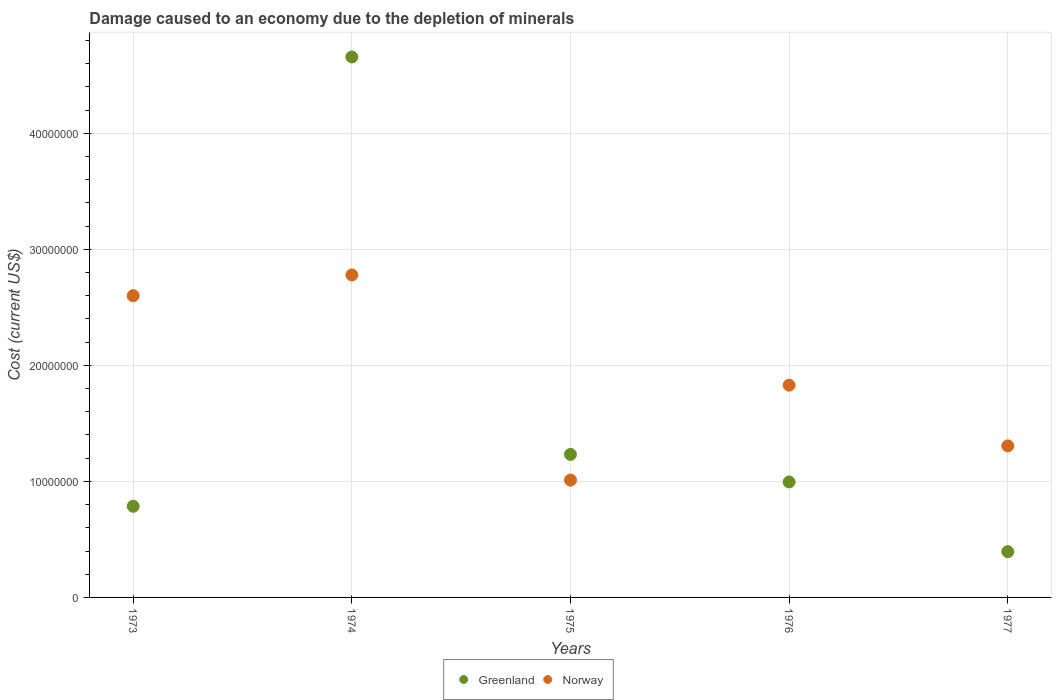How many different coloured dotlines are there?
Keep it short and to the point. 2. What is the cost of damage caused due to the depletion of minerals in Norway in 1975?
Offer a terse response. 1.01e+07. Across all years, what is the maximum cost of damage caused due to the depletion of minerals in Norway?
Give a very brief answer. 2.78e+07. Across all years, what is the minimum cost of damage caused due to the depletion of minerals in Norway?
Make the answer very short. 1.01e+07. In which year was the cost of damage caused due to the depletion of minerals in Norway maximum?
Provide a short and direct response. 1974. In which year was the cost of damage caused due to the depletion of minerals in Norway minimum?
Your answer should be very brief. 1975. What is the total cost of damage caused due to the depletion of minerals in Norway in the graph?
Ensure brevity in your answer.  9.53e+07. What is the difference between the cost of damage caused due to the depletion of minerals in Norway in 1974 and that in 1976?
Provide a succinct answer. 9.50e+06. What is the difference between the cost of damage caused due to the depletion of minerals in Greenland in 1975 and the cost of damage caused due to the depletion of minerals in Norway in 1974?
Your response must be concise. -1.55e+07. What is the average cost of damage caused due to the depletion of minerals in Norway per year?
Ensure brevity in your answer.  1.91e+07. In the year 1973, what is the difference between the cost of damage caused due to the depletion of minerals in Norway and cost of damage caused due to the depletion of minerals in Greenland?
Your response must be concise. 1.82e+07. What is the ratio of the cost of damage caused due to the depletion of minerals in Norway in 1974 to that in 1976?
Your answer should be very brief. 1.52. Is the cost of damage caused due to the depletion of minerals in Greenland in 1973 less than that in 1975?
Your answer should be compact. Yes. Is the difference between the cost of damage caused due to the depletion of minerals in Norway in 1976 and 1977 greater than the difference between the cost of damage caused due to the depletion of minerals in Greenland in 1976 and 1977?
Ensure brevity in your answer.  No. What is the difference between the highest and the second highest cost of damage caused due to the depletion of minerals in Norway?
Your answer should be compact. 1.79e+06. What is the difference between the highest and the lowest cost of damage caused due to the depletion of minerals in Norway?
Offer a terse response. 1.77e+07. Does the cost of damage caused due to the depletion of minerals in Norway monotonically increase over the years?
Keep it short and to the point. No. Is the cost of damage caused due to the depletion of minerals in Norway strictly greater than the cost of damage caused due to the depletion of minerals in Greenland over the years?
Ensure brevity in your answer.  No. How many dotlines are there?
Ensure brevity in your answer.  2. What is the difference between two consecutive major ticks on the Y-axis?
Your answer should be compact. 1.00e+07. Are the values on the major ticks of Y-axis written in scientific E-notation?
Provide a short and direct response. No. How are the legend labels stacked?
Provide a succinct answer. Horizontal. What is the title of the graph?
Offer a very short reply. Damage caused to an economy due to the depletion of minerals. Does "Hungary" appear as one of the legend labels in the graph?
Give a very brief answer. No. What is the label or title of the X-axis?
Offer a terse response. Years. What is the label or title of the Y-axis?
Ensure brevity in your answer.  Cost (current US$). What is the Cost (current US$) in Greenland in 1973?
Offer a terse response. 7.86e+06. What is the Cost (current US$) of Norway in 1973?
Offer a very short reply. 2.60e+07. What is the Cost (current US$) in Greenland in 1974?
Your answer should be very brief. 4.66e+07. What is the Cost (current US$) of Norway in 1974?
Provide a short and direct response. 2.78e+07. What is the Cost (current US$) of Greenland in 1975?
Offer a very short reply. 1.23e+07. What is the Cost (current US$) of Norway in 1975?
Provide a succinct answer. 1.01e+07. What is the Cost (current US$) in Greenland in 1976?
Your answer should be very brief. 9.95e+06. What is the Cost (current US$) in Norway in 1976?
Make the answer very short. 1.83e+07. What is the Cost (current US$) in Greenland in 1977?
Your answer should be very brief. 3.94e+06. What is the Cost (current US$) in Norway in 1977?
Make the answer very short. 1.31e+07. Across all years, what is the maximum Cost (current US$) of Greenland?
Provide a short and direct response. 4.66e+07. Across all years, what is the maximum Cost (current US$) in Norway?
Make the answer very short. 2.78e+07. Across all years, what is the minimum Cost (current US$) in Greenland?
Provide a short and direct response. 3.94e+06. Across all years, what is the minimum Cost (current US$) of Norway?
Make the answer very short. 1.01e+07. What is the total Cost (current US$) of Greenland in the graph?
Offer a very short reply. 8.07e+07. What is the total Cost (current US$) of Norway in the graph?
Ensure brevity in your answer.  9.53e+07. What is the difference between the Cost (current US$) of Greenland in 1973 and that in 1974?
Make the answer very short. -3.87e+07. What is the difference between the Cost (current US$) in Norway in 1973 and that in 1974?
Provide a succinct answer. -1.79e+06. What is the difference between the Cost (current US$) in Greenland in 1973 and that in 1975?
Your answer should be very brief. -4.47e+06. What is the difference between the Cost (current US$) in Norway in 1973 and that in 1975?
Provide a short and direct response. 1.59e+07. What is the difference between the Cost (current US$) in Greenland in 1973 and that in 1976?
Provide a succinct answer. -2.10e+06. What is the difference between the Cost (current US$) of Norway in 1973 and that in 1976?
Provide a succinct answer. 7.71e+06. What is the difference between the Cost (current US$) of Greenland in 1973 and that in 1977?
Keep it short and to the point. 3.91e+06. What is the difference between the Cost (current US$) of Norway in 1973 and that in 1977?
Provide a short and direct response. 1.29e+07. What is the difference between the Cost (current US$) of Greenland in 1974 and that in 1975?
Provide a succinct answer. 3.43e+07. What is the difference between the Cost (current US$) of Norway in 1974 and that in 1975?
Give a very brief answer. 1.77e+07. What is the difference between the Cost (current US$) of Greenland in 1974 and that in 1976?
Provide a short and direct response. 3.66e+07. What is the difference between the Cost (current US$) in Norway in 1974 and that in 1976?
Keep it short and to the point. 9.50e+06. What is the difference between the Cost (current US$) in Greenland in 1974 and that in 1977?
Make the answer very short. 4.26e+07. What is the difference between the Cost (current US$) of Norway in 1974 and that in 1977?
Offer a very short reply. 1.47e+07. What is the difference between the Cost (current US$) of Greenland in 1975 and that in 1976?
Your response must be concise. 2.37e+06. What is the difference between the Cost (current US$) of Norway in 1975 and that in 1976?
Offer a very short reply. -8.18e+06. What is the difference between the Cost (current US$) in Greenland in 1975 and that in 1977?
Provide a succinct answer. 8.38e+06. What is the difference between the Cost (current US$) in Norway in 1975 and that in 1977?
Give a very brief answer. -2.95e+06. What is the difference between the Cost (current US$) of Greenland in 1976 and that in 1977?
Make the answer very short. 6.01e+06. What is the difference between the Cost (current US$) in Norway in 1976 and that in 1977?
Provide a succinct answer. 5.23e+06. What is the difference between the Cost (current US$) in Greenland in 1973 and the Cost (current US$) in Norway in 1974?
Your response must be concise. -1.99e+07. What is the difference between the Cost (current US$) in Greenland in 1973 and the Cost (current US$) in Norway in 1975?
Your response must be concise. -2.25e+06. What is the difference between the Cost (current US$) in Greenland in 1973 and the Cost (current US$) in Norway in 1976?
Provide a short and direct response. -1.04e+07. What is the difference between the Cost (current US$) in Greenland in 1973 and the Cost (current US$) in Norway in 1977?
Ensure brevity in your answer.  -5.20e+06. What is the difference between the Cost (current US$) of Greenland in 1974 and the Cost (current US$) of Norway in 1975?
Keep it short and to the point. 3.65e+07. What is the difference between the Cost (current US$) of Greenland in 1974 and the Cost (current US$) of Norway in 1976?
Offer a terse response. 2.83e+07. What is the difference between the Cost (current US$) in Greenland in 1974 and the Cost (current US$) in Norway in 1977?
Your answer should be very brief. 3.35e+07. What is the difference between the Cost (current US$) in Greenland in 1975 and the Cost (current US$) in Norway in 1976?
Ensure brevity in your answer.  -5.97e+06. What is the difference between the Cost (current US$) of Greenland in 1975 and the Cost (current US$) of Norway in 1977?
Your answer should be compact. -7.35e+05. What is the difference between the Cost (current US$) in Greenland in 1976 and the Cost (current US$) in Norway in 1977?
Provide a succinct answer. -3.11e+06. What is the average Cost (current US$) in Greenland per year?
Your answer should be compact. 1.61e+07. What is the average Cost (current US$) in Norway per year?
Provide a short and direct response. 1.91e+07. In the year 1973, what is the difference between the Cost (current US$) in Greenland and Cost (current US$) in Norway?
Provide a succinct answer. -1.82e+07. In the year 1974, what is the difference between the Cost (current US$) in Greenland and Cost (current US$) in Norway?
Offer a terse response. 1.88e+07. In the year 1975, what is the difference between the Cost (current US$) of Greenland and Cost (current US$) of Norway?
Your response must be concise. 2.21e+06. In the year 1976, what is the difference between the Cost (current US$) of Greenland and Cost (current US$) of Norway?
Provide a short and direct response. -8.34e+06. In the year 1977, what is the difference between the Cost (current US$) of Greenland and Cost (current US$) of Norway?
Make the answer very short. -9.12e+06. What is the ratio of the Cost (current US$) of Greenland in 1973 to that in 1974?
Provide a short and direct response. 0.17. What is the ratio of the Cost (current US$) in Norway in 1973 to that in 1974?
Make the answer very short. 0.94. What is the ratio of the Cost (current US$) in Greenland in 1973 to that in 1975?
Your response must be concise. 0.64. What is the ratio of the Cost (current US$) of Norway in 1973 to that in 1975?
Give a very brief answer. 2.57. What is the ratio of the Cost (current US$) in Greenland in 1973 to that in 1976?
Provide a short and direct response. 0.79. What is the ratio of the Cost (current US$) in Norway in 1973 to that in 1976?
Provide a succinct answer. 1.42. What is the ratio of the Cost (current US$) in Greenland in 1973 to that in 1977?
Give a very brief answer. 1.99. What is the ratio of the Cost (current US$) in Norway in 1973 to that in 1977?
Offer a very short reply. 1.99. What is the ratio of the Cost (current US$) in Greenland in 1974 to that in 1975?
Provide a short and direct response. 3.78. What is the ratio of the Cost (current US$) in Norway in 1974 to that in 1975?
Your response must be concise. 2.75. What is the ratio of the Cost (current US$) of Greenland in 1974 to that in 1976?
Provide a short and direct response. 4.68. What is the ratio of the Cost (current US$) of Norway in 1974 to that in 1976?
Provide a succinct answer. 1.52. What is the ratio of the Cost (current US$) of Greenland in 1974 to that in 1977?
Give a very brief answer. 11.81. What is the ratio of the Cost (current US$) in Norway in 1974 to that in 1977?
Make the answer very short. 2.13. What is the ratio of the Cost (current US$) in Greenland in 1975 to that in 1976?
Offer a very short reply. 1.24. What is the ratio of the Cost (current US$) of Norway in 1975 to that in 1976?
Your response must be concise. 0.55. What is the ratio of the Cost (current US$) in Greenland in 1975 to that in 1977?
Provide a short and direct response. 3.13. What is the ratio of the Cost (current US$) of Norway in 1975 to that in 1977?
Keep it short and to the point. 0.77. What is the ratio of the Cost (current US$) in Greenland in 1976 to that in 1977?
Your answer should be very brief. 2.52. What is the ratio of the Cost (current US$) of Norway in 1976 to that in 1977?
Your answer should be compact. 1.4. What is the difference between the highest and the second highest Cost (current US$) of Greenland?
Offer a terse response. 3.43e+07. What is the difference between the highest and the second highest Cost (current US$) in Norway?
Make the answer very short. 1.79e+06. What is the difference between the highest and the lowest Cost (current US$) in Greenland?
Provide a short and direct response. 4.26e+07. What is the difference between the highest and the lowest Cost (current US$) in Norway?
Offer a terse response. 1.77e+07. 